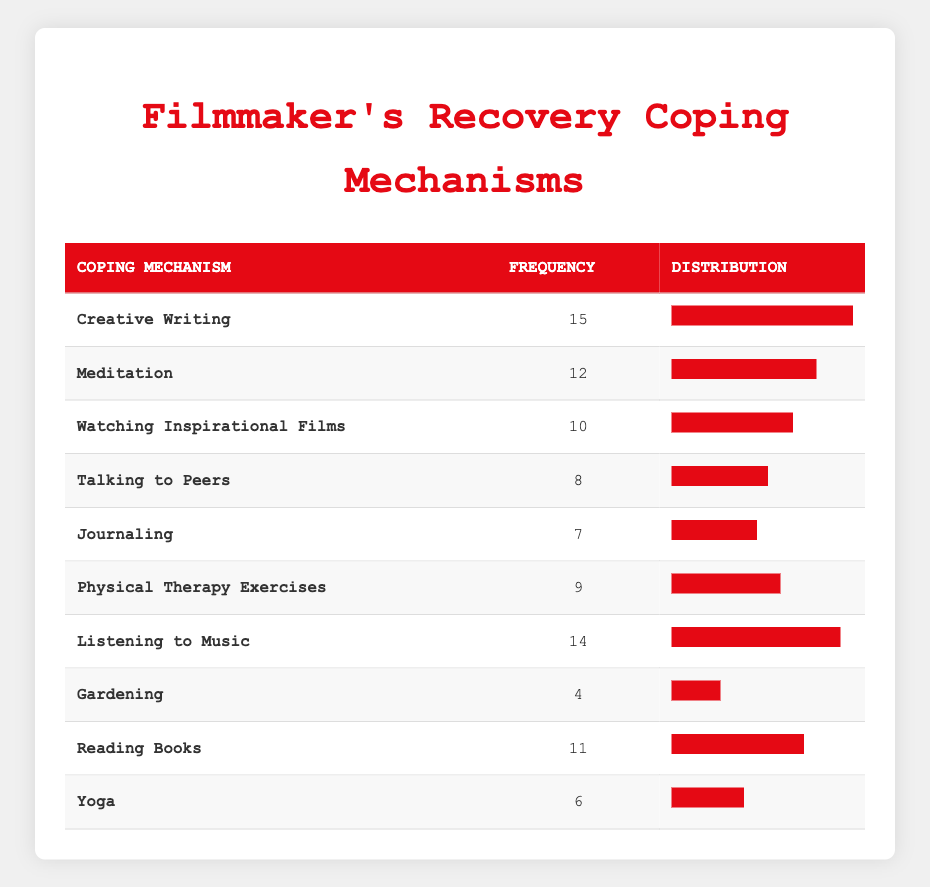What coping mechanism has the highest frequency? By scanning the frequency column, the coping mechanism "Creative Writing" is at the top with a frequency of 15, more than any other listed option.
Answer: Creative Writing Is "Listening to Music" used more frequently than "Reading Books"? "Listening to Music" has a frequency of 14 and "Reading Books" has a frequency of 11. Since 14 is greater than 11, Music is used more frequently.
Answer: Yes What is the total frequency of all coping mechanisms listed? To find the total frequency, sum the frequencies: 15 + 12 + 10 + 8 + 7 + 9 + 14 + 4 + 11 + 6 = 96.
Answer: 96 Which coping mechanism has the lowest frequency, and what is its value? Upon reviewing the table, "Gardening" has the lowest frequency of 4 compared to all other mechanisms.
Answer: Gardening, 4 What is the average frequency of the coping mechanisms? To calculate the average, first sum the frequencies (96) and divide by the number of mechanisms (10): 96 / 10 = 9.6.
Answer: 9.6 How many coping mechanisms have a frequency greater than or equal to 10? The mechanisms with a frequency of 10 or more are "Creative Writing," "Listening to Music," "Meditation," "Reading Books," and "Watching Inspirational Films," totaling 5 mechanisms.
Answer: 5 Is the frequency of "Yoga" greater than that of "Journaling"? "Yoga" has a frequency of 6 and "Journaling" has a frequency of 7. Since 6 is less than 7, Yoga does not have a higher frequency.
Answer: No What coping mechanism has a frequency of 7? Scanning the mechanisms, "Journaling" is confirmed to have a frequency of 7.
Answer: Journaling 